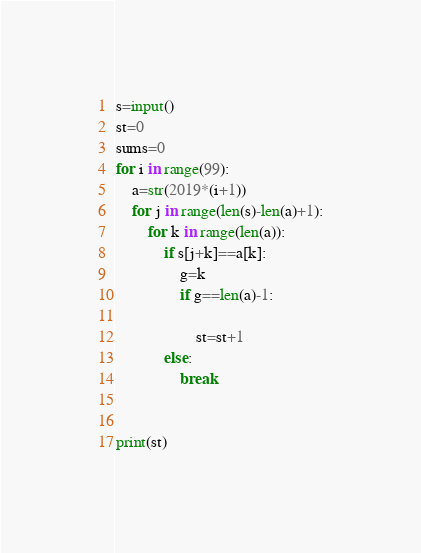<code> <loc_0><loc_0><loc_500><loc_500><_Python_>s=input()
st=0
sums=0
for i in range(99):
    a=str(2019*(i+1))
    for j in range(len(s)-len(a)+1):
        for k in range(len(a)):
            if s[j+k]==a[k]:
                g=k
                if g==len(a)-1:
                    
                    st=st+1
            else:
                break
            
    
print(st)</code> 